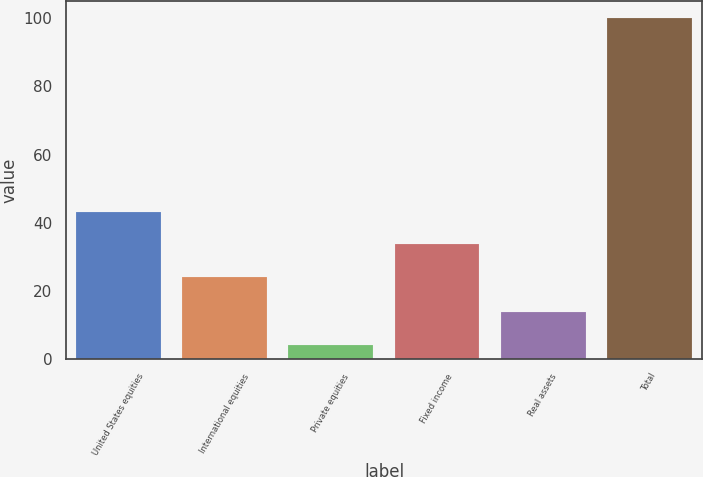Convert chart to OTSL. <chart><loc_0><loc_0><loc_500><loc_500><bar_chart><fcel>United States equities<fcel>International equities<fcel>Private equities<fcel>Fixed income<fcel>Real assets<fcel>Total<nl><fcel>43.28<fcel>24.1<fcel>4.1<fcel>33.69<fcel>13.69<fcel>100<nl></chart> 